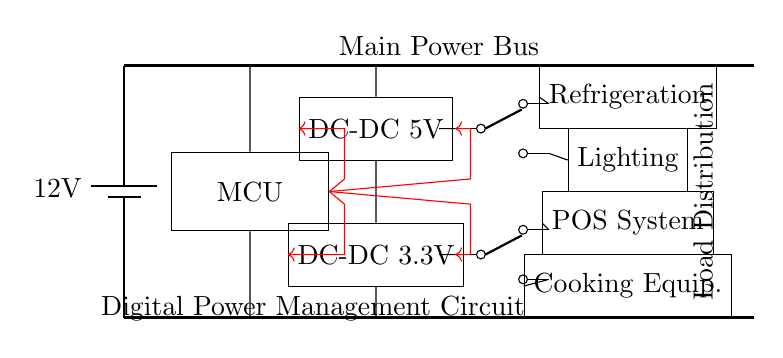What is the main power source voltage? The schematic shows a battery with a label indicating it provides a voltage of 12 volts. This is clearly marked at the top of the power source component in the diagram.
Answer: 12 volts What types of DC-DC converters are present in the circuit? The diagram includes two DC-DC converters labeled with their output voltages: one converter outputs 5 volts and the other outputs 3.3 volts. This is visible in the labeled rectangles in the circuit.
Answer: 5 volts and 3.3 volts How many loads are connected to the circuit? There are four distinct load components drawn in the circuit: refrigeration, lighting, POS system, and cooking equipment. Each is represented as a rectangle in the bottom section of the diagram.
Answer: Four What is the function of the microcontroller in this circuit? The microcontroller, labeled "MCU," is responsible for controlling power distribution as it has control lines directing power to the DC-DC converters and switches. This can be inferred from the red control lines connecting it to various components.
Answer: Control power distribution Which component connects the microcontroller to the 5V DC-DC converter? The microcontroller is connected to the 5V DC-DC converter through a red control line marked from the MCU to the DC converter. The line indicates that the microcontroller governs the operational state of the converter.
Answer: Control line What are the types of switches used in this circuit? The switches in the diagram are labeled as "spdt," indicating that they are single-pole double-throw switches. This can be seen in the labels next to the switch symbols in the schematic.
Answer: Single-pole double-throw 